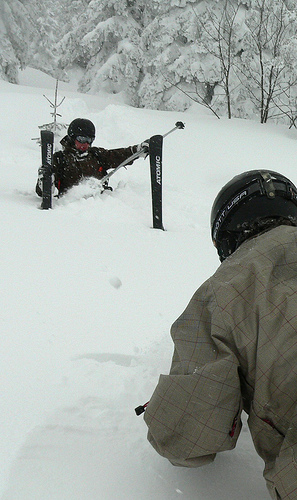Read all the text in this image. USA 